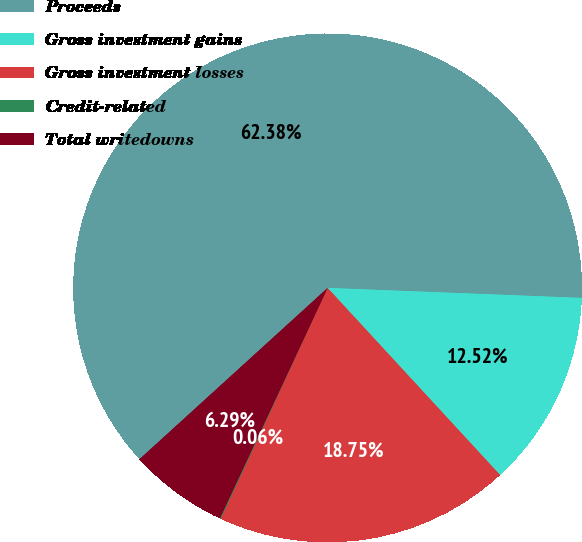Convert chart to OTSL. <chart><loc_0><loc_0><loc_500><loc_500><pie_chart><fcel>Proceeds<fcel>Gross investment gains<fcel>Gross investment losses<fcel>Credit-related<fcel>Total writedowns<nl><fcel>62.37%<fcel>12.52%<fcel>18.75%<fcel>0.06%<fcel>6.29%<nl></chart> 